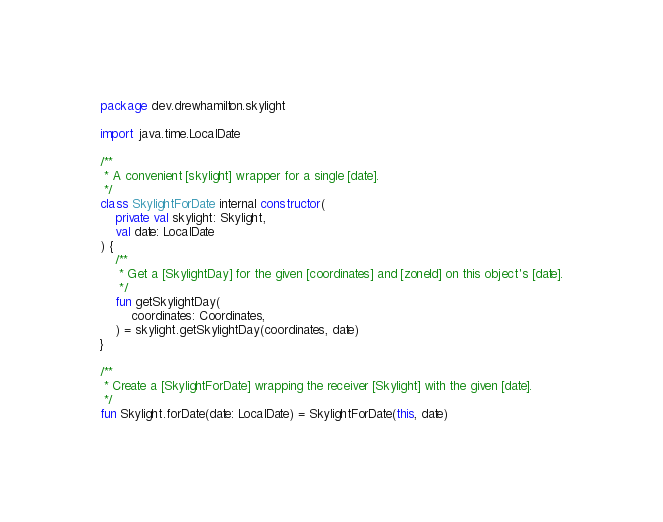<code> <loc_0><loc_0><loc_500><loc_500><_Kotlin_>package dev.drewhamilton.skylight

import java.time.LocalDate

/**
 * A convenient [skylight] wrapper for a single [date].
 */
class SkylightForDate internal constructor(
    private val skylight: Skylight,
    val date: LocalDate
) {
    /**
     * Get a [SkylightDay] for the given [coordinates] and [zoneId] on this object's [date].
     */
    fun getSkylightDay(
        coordinates: Coordinates,
    ) = skylight.getSkylightDay(coordinates, date)
}

/**
 * Create a [SkylightForDate] wrapping the receiver [Skylight] with the given [date].
 */
fun Skylight.forDate(date: LocalDate) = SkylightForDate(this, date)
</code> 